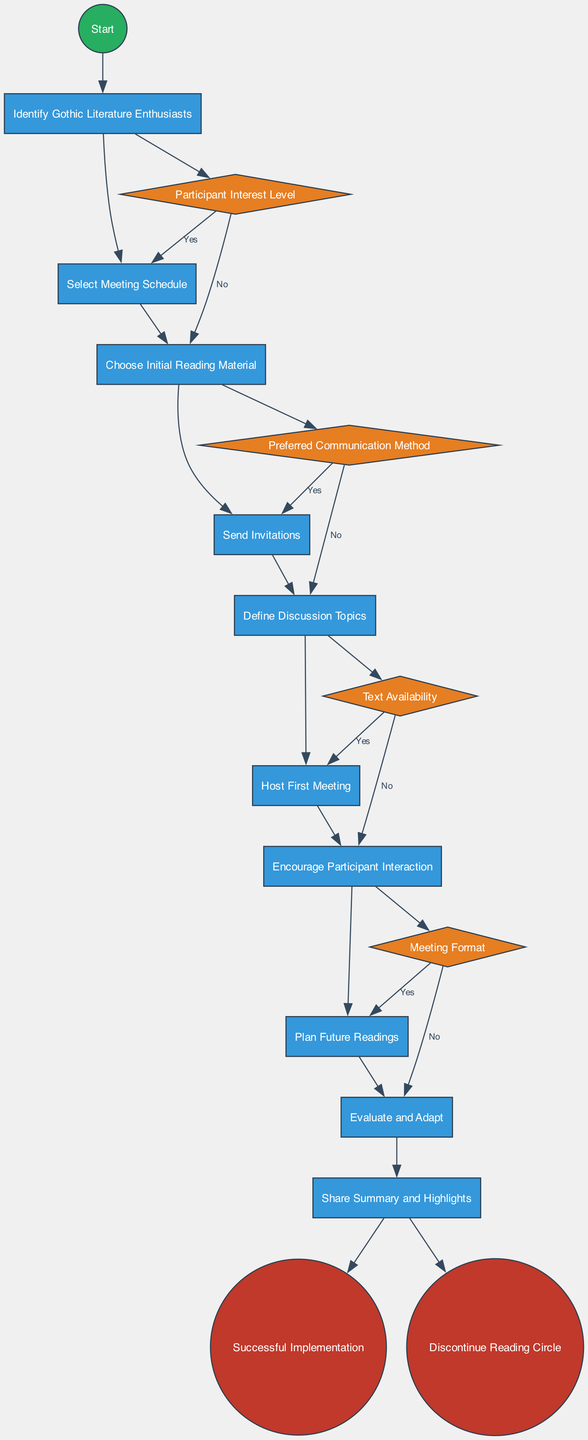What is the first activity in the diagram? The first activity listed in the diagram is "Identify Gothic Literature Enthusiasts". This can be found after the start node, indicating that it is the initial step in the process.
Answer: Identify Gothic Literature Enthusiasts How many activities are included in the diagram? The diagram lists a total of ten activities related to organizing the reading circle. This is determined by counting each activity node included.
Answer: Ten What are the two endpoints of the diagram? The endpoints of the diagram are "Successful Implementation" and "Discontinue Reading Circle". These two are at the end of the activity flow and represent the outcomes.
Answer: Successful Implementation, Discontinue Reading Circle What is the decision point regarding text availability? The decision point concerning text availability is labeled "Text Availability". This can be found in the section of decision points in the diagram that deals with ensuring texts are accessible.
Answer: Text Availability How many decision points are shown in the diagram? There are four decision points illustrated in the diagram, which can be counted directly in the decision points section.
Answer: Four If the participant interest level is low, what is the next action likely to be? If the participant interest level is assessed as low at the decision point, the next action is to proceed to "Discontinue Reading Circle", as indicated by the 'No' edge leading to the endpoint.
Answer: Discontinue Reading Circle What does the decision point "Preferred Communication Method" affect? The decision point "Preferred Communication Method" affects how invitations and summaries are communicated to participants, indicating what medium will be most effective for correspondence.
Answer: Communication medium Which activities are connected directly to the end point "Successful Implementation"? The activity "Evaluate and Adapt" connects directly to the endpoint "Successful Implementation" in a flow that signifies a positive outcome leading to continuation.
Answer: Evaluate and Adapt What activity follows "Send Invitations" after the decision about participant interest level? After sending invitations and considering participant interest, assuming there is sufficient interest, the next activity is "Host First Meeting". This follows the flow from the decision point if the answer is yes.
Answer: Host First Meeting 